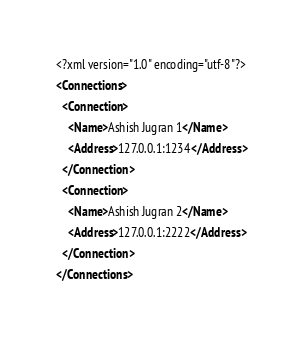<code> <loc_0><loc_0><loc_500><loc_500><_XML_><?xml version="1.0" encoding="utf-8"?>
<Connections>
  <Connection>
    <Name>Ashish Jugran 1</Name>
    <Address>127.0.0.1:1234</Address>
  </Connection>
  <Connection>
    <Name>Ashish Jugran 2</Name>
    <Address>127.0.0.1:2222</Address>
  </Connection>
</Connections></code> 